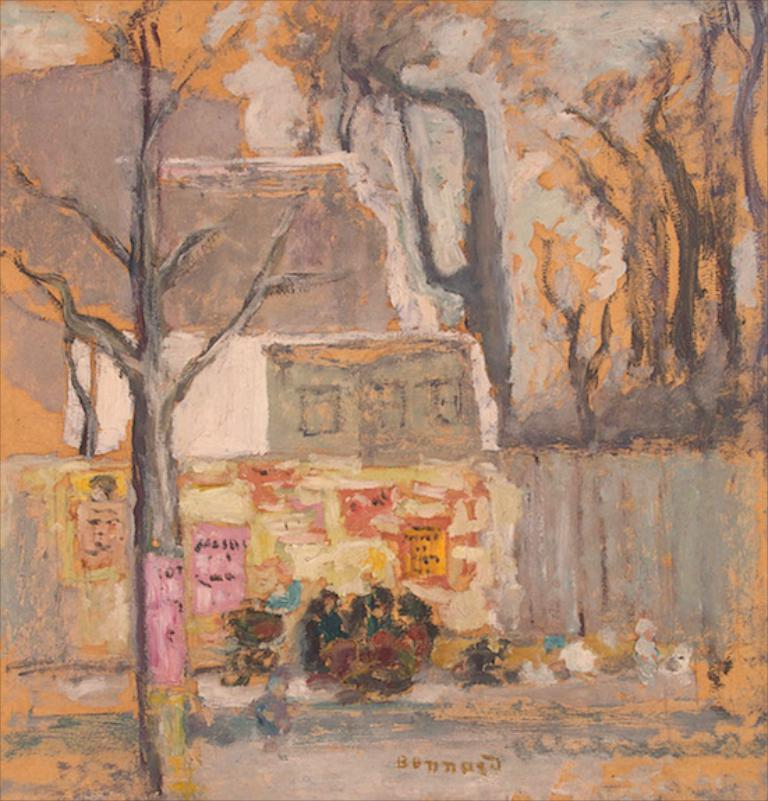What is depicted in the painting in the image? There is a painting of a tree in the image. What else can be seen in the image besides the painting? There is a wall in the image. What type of bean is growing on the tree in the image? There is no bean growing on the tree in the image, as it is a painting of a tree and not a real tree. 